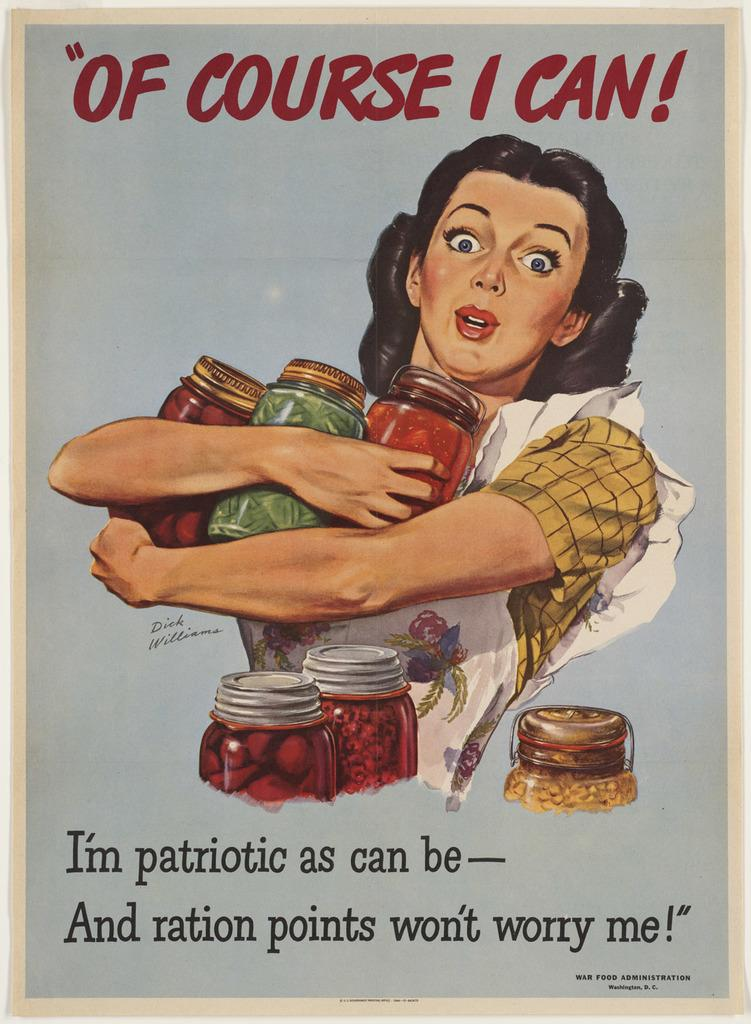<image>
Create a compact narrative representing the image presented. A picture of a woman carrying food items is captioned with the words of course I can. 